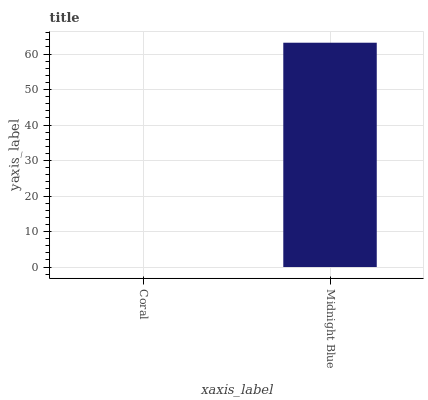Is Midnight Blue the minimum?
Answer yes or no. No. Is Midnight Blue greater than Coral?
Answer yes or no. Yes. Is Coral less than Midnight Blue?
Answer yes or no. Yes. Is Coral greater than Midnight Blue?
Answer yes or no. No. Is Midnight Blue less than Coral?
Answer yes or no. No. Is Midnight Blue the high median?
Answer yes or no. Yes. Is Coral the low median?
Answer yes or no. Yes. Is Coral the high median?
Answer yes or no. No. Is Midnight Blue the low median?
Answer yes or no. No. 